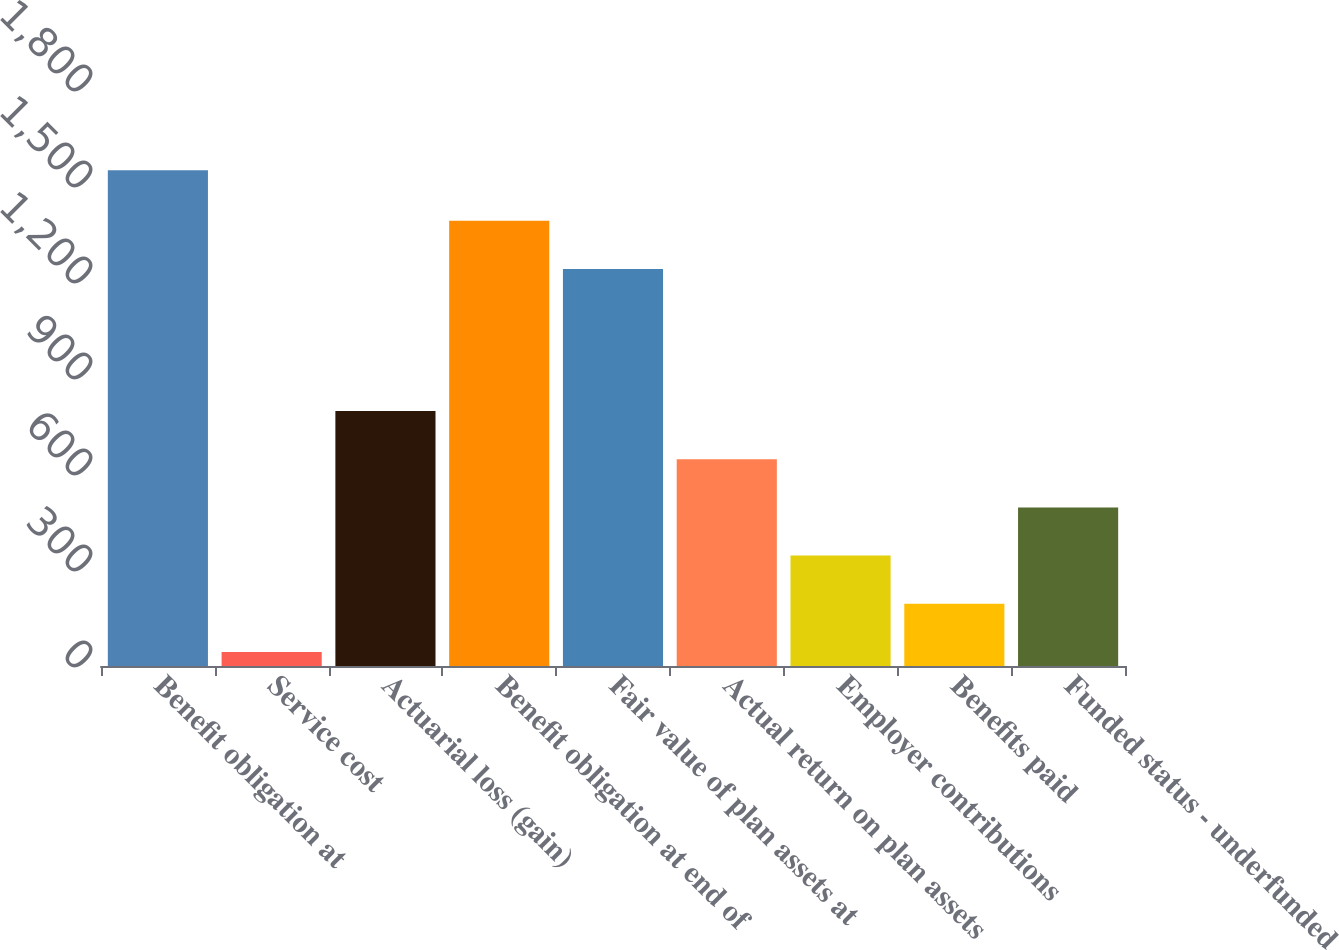Convert chart. <chart><loc_0><loc_0><loc_500><loc_500><bar_chart><fcel>Benefit obligation at<fcel>Service cost<fcel>Actuarial loss (gain)<fcel>Benefit obligation at end of<fcel>Fair value of plan assets at<fcel>Actual return on plan assets<fcel>Employer contributions<fcel>Benefits paid<fcel>Funded status - underfunded<nl><fcel>1549<fcel>44<fcel>796.5<fcel>1391.5<fcel>1241<fcel>646<fcel>345<fcel>194.5<fcel>495.5<nl></chart> 